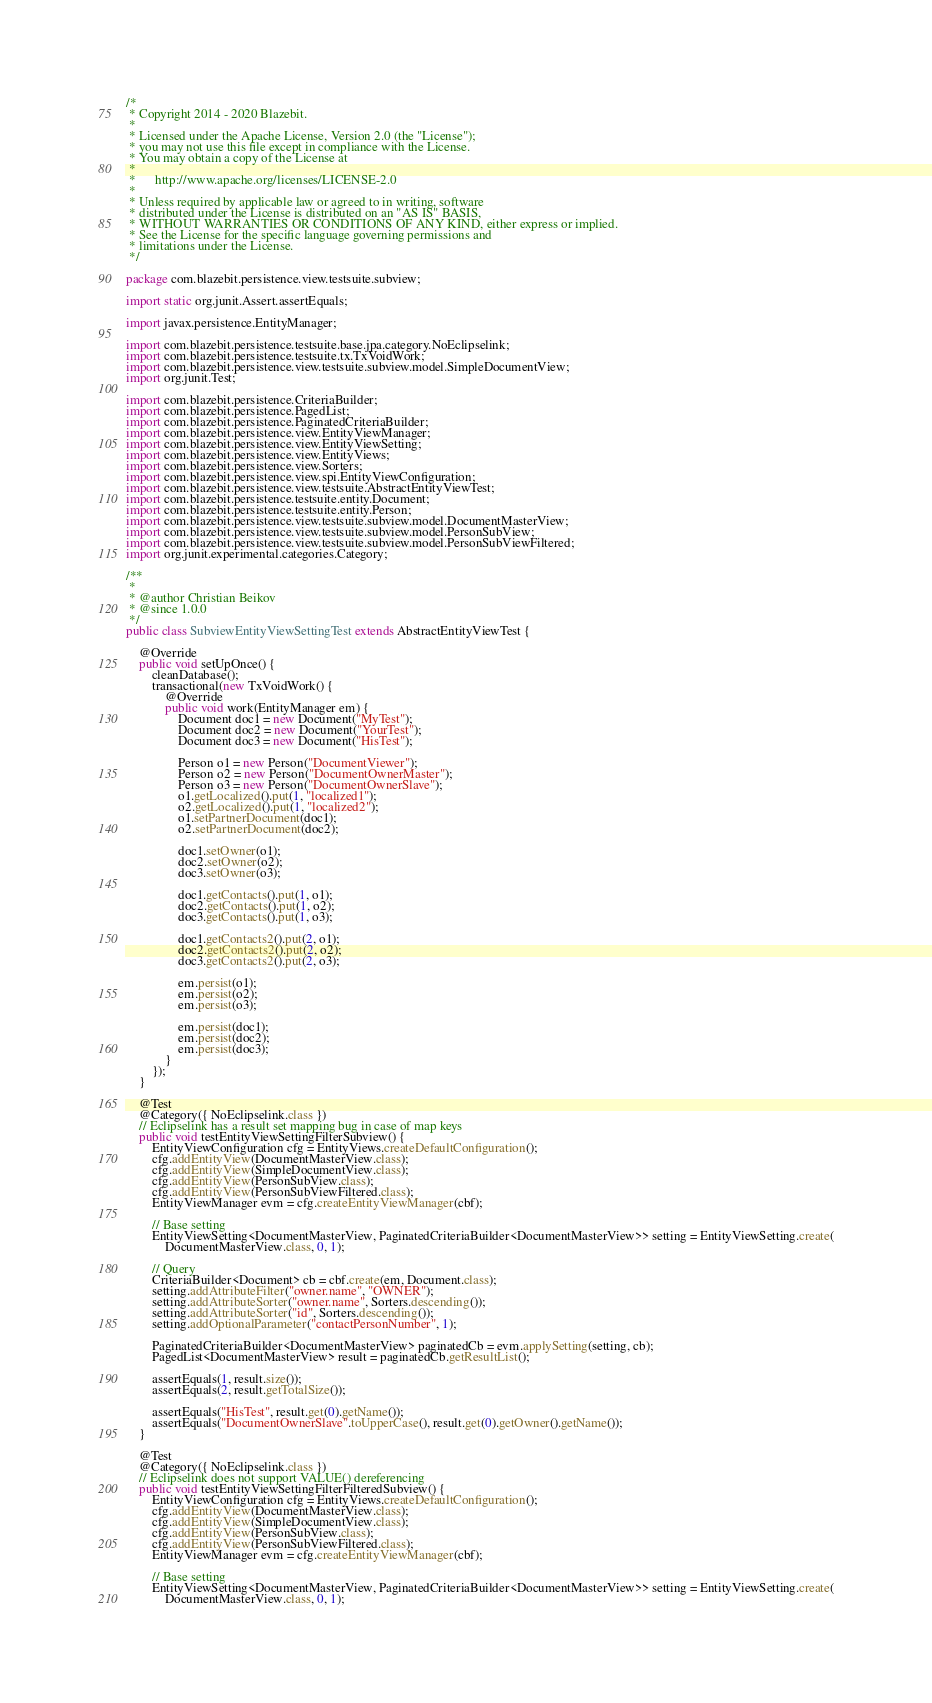<code> <loc_0><loc_0><loc_500><loc_500><_Java_>/*
 * Copyright 2014 - 2020 Blazebit.
 *
 * Licensed under the Apache License, Version 2.0 (the "License");
 * you may not use this file except in compliance with the License.
 * You may obtain a copy of the License at
 *
 *      http://www.apache.org/licenses/LICENSE-2.0
 *
 * Unless required by applicable law or agreed to in writing, software
 * distributed under the License is distributed on an "AS IS" BASIS,
 * WITHOUT WARRANTIES OR CONDITIONS OF ANY KIND, either express or implied.
 * See the License for the specific language governing permissions and
 * limitations under the License.
 */

package com.blazebit.persistence.view.testsuite.subview;

import static org.junit.Assert.assertEquals;

import javax.persistence.EntityManager;

import com.blazebit.persistence.testsuite.base.jpa.category.NoEclipselink;
import com.blazebit.persistence.testsuite.tx.TxVoidWork;
import com.blazebit.persistence.view.testsuite.subview.model.SimpleDocumentView;
import org.junit.Test;

import com.blazebit.persistence.CriteriaBuilder;
import com.blazebit.persistence.PagedList;
import com.blazebit.persistence.PaginatedCriteriaBuilder;
import com.blazebit.persistence.view.EntityViewManager;
import com.blazebit.persistence.view.EntityViewSetting;
import com.blazebit.persistence.view.EntityViews;
import com.blazebit.persistence.view.Sorters;
import com.blazebit.persistence.view.spi.EntityViewConfiguration;
import com.blazebit.persistence.view.testsuite.AbstractEntityViewTest;
import com.blazebit.persistence.testsuite.entity.Document;
import com.blazebit.persistence.testsuite.entity.Person;
import com.blazebit.persistence.view.testsuite.subview.model.DocumentMasterView;
import com.blazebit.persistence.view.testsuite.subview.model.PersonSubView;
import com.blazebit.persistence.view.testsuite.subview.model.PersonSubViewFiltered;
import org.junit.experimental.categories.Category;

/**
 *
 * @author Christian Beikov
 * @since 1.0.0
 */
public class SubviewEntityViewSettingTest extends AbstractEntityViewTest {

    @Override
    public void setUpOnce() {
        cleanDatabase();
        transactional(new TxVoidWork() {
            @Override
            public void work(EntityManager em) {
                Document doc1 = new Document("MyTest");
                Document doc2 = new Document("YourTest");
                Document doc3 = new Document("HisTest");

                Person o1 = new Person("DocumentViewer");
                Person o2 = new Person("DocumentOwnerMaster");
                Person o3 = new Person("DocumentOwnerSlave");
                o1.getLocalized().put(1, "localized1");
                o2.getLocalized().put(1, "localized2");
                o1.setPartnerDocument(doc1);
                o2.setPartnerDocument(doc2);

                doc1.setOwner(o1);
                doc2.setOwner(o2);
                doc3.setOwner(o3);

                doc1.getContacts().put(1, o1);
                doc2.getContacts().put(1, o2);
                doc3.getContacts().put(1, o3);

                doc1.getContacts2().put(2, o1);
                doc2.getContacts2().put(2, o2);
                doc3.getContacts2().put(2, o3);

                em.persist(o1);
                em.persist(o2);
                em.persist(o3);

                em.persist(doc1);
                em.persist(doc2);
                em.persist(doc3);
            }
        });
    }

    @Test
    @Category({ NoEclipselink.class })
    // Eclipselink has a result set mapping bug in case of map keys
    public void testEntityViewSettingFilterSubview() {
        EntityViewConfiguration cfg = EntityViews.createDefaultConfiguration();
        cfg.addEntityView(DocumentMasterView.class);
        cfg.addEntityView(SimpleDocumentView.class);
        cfg.addEntityView(PersonSubView.class);
        cfg.addEntityView(PersonSubViewFiltered.class);
        EntityViewManager evm = cfg.createEntityViewManager(cbf);

        // Base setting
        EntityViewSetting<DocumentMasterView, PaginatedCriteriaBuilder<DocumentMasterView>> setting = EntityViewSetting.create(
            DocumentMasterView.class, 0, 1);

        // Query
        CriteriaBuilder<Document> cb = cbf.create(em, Document.class);
        setting.addAttributeFilter("owner.name", "OWNER");
        setting.addAttributeSorter("owner.name", Sorters.descending());
        setting.addAttributeSorter("id", Sorters.descending());
        setting.addOptionalParameter("contactPersonNumber", 1);

        PaginatedCriteriaBuilder<DocumentMasterView> paginatedCb = evm.applySetting(setting, cb);
        PagedList<DocumentMasterView> result = paginatedCb.getResultList();

        assertEquals(1, result.size());
        assertEquals(2, result.getTotalSize());

        assertEquals("HisTest", result.get(0).getName());
        assertEquals("DocumentOwnerSlave".toUpperCase(), result.get(0).getOwner().getName());
    }

    @Test
    @Category({ NoEclipselink.class })
    // Eclipselink does not support VALUE() dereferencing
    public void testEntityViewSettingFilterFilteredSubview() {
        EntityViewConfiguration cfg = EntityViews.createDefaultConfiguration();
        cfg.addEntityView(DocumentMasterView.class);
        cfg.addEntityView(SimpleDocumentView.class);
        cfg.addEntityView(PersonSubView.class);
        cfg.addEntityView(PersonSubViewFiltered.class);
        EntityViewManager evm = cfg.createEntityViewManager(cbf);

        // Base setting
        EntityViewSetting<DocumentMasterView, PaginatedCriteriaBuilder<DocumentMasterView>> setting = EntityViewSetting.create(
            DocumentMasterView.class, 0, 1);
</code> 